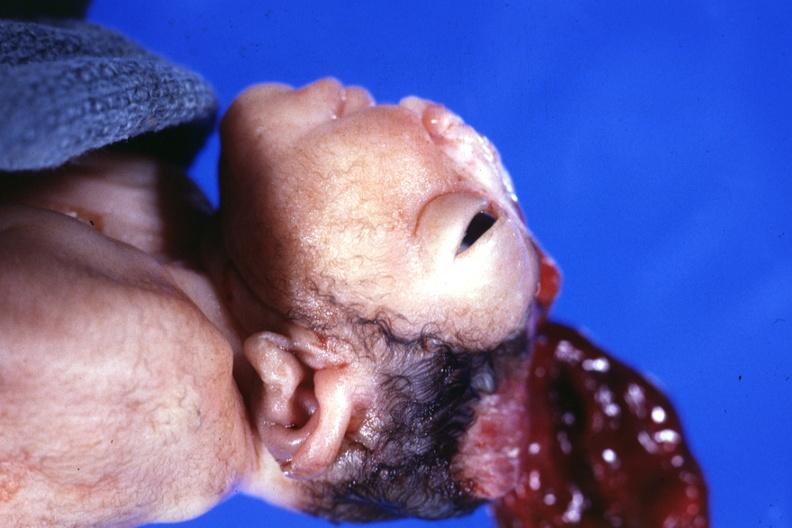s excellent example of peritoneal carcinomatosis with implants on serosal surfaces of uterus and ovaries present?
Answer the question using a single word or phrase. No 